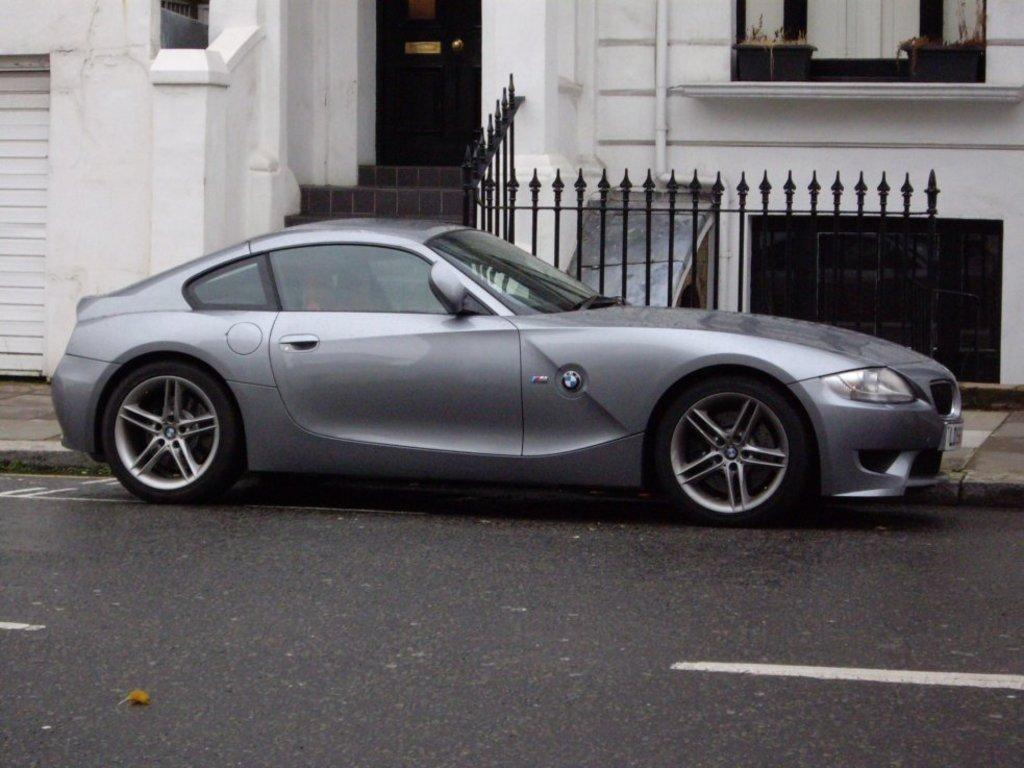What is the main subject of the image? There is a car on the road in the image. What can be seen in the background of the image? There is a building and fencing in the background of the image. Can you describe the building in the image? The building has a door. How many toys can be seen on the roof of the car in the image? There are no toys visible on the car in the image. What type of shoe is the car wearing in the image? Cars do not wear shoes, so this question cannot be answered. 